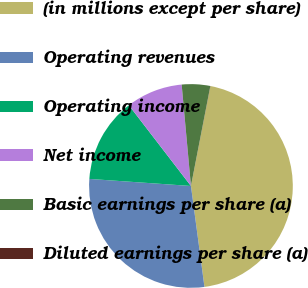<chart> <loc_0><loc_0><loc_500><loc_500><pie_chart><fcel>(in millions except per share)<fcel>Operating revenues<fcel>Operating income<fcel>Net income<fcel>Basic earnings per share (a)<fcel>Diluted earnings per share (a)<nl><fcel>44.81%<fcel>28.22%<fcel>13.46%<fcel>8.98%<fcel>4.5%<fcel>0.02%<nl></chart> 